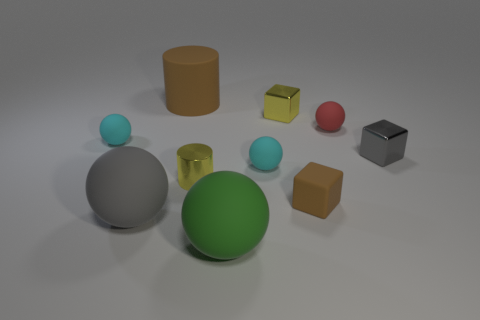Subtract all green balls. How many balls are left? 4 Subtract all green spheres. How many spheres are left? 4 Subtract 1 cylinders. How many cylinders are left? 1 Add 1 large brown cylinders. How many large brown cylinders are left? 2 Add 8 large gray cylinders. How many large gray cylinders exist? 8 Subtract 0 green cylinders. How many objects are left? 10 Subtract all cylinders. How many objects are left? 8 Subtract all yellow balls. Subtract all cyan blocks. How many balls are left? 5 Subtract all blue blocks. How many cyan spheres are left? 2 Subtract all small red things. Subtract all yellow matte cubes. How many objects are left? 9 